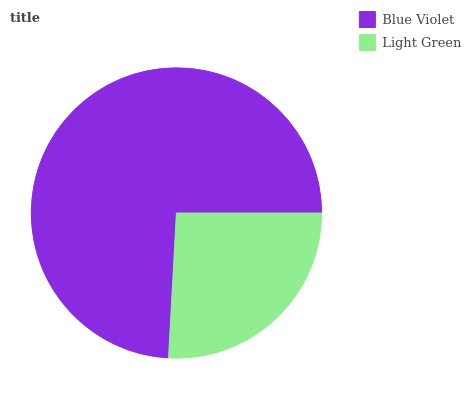Is Light Green the minimum?
Answer yes or no. Yes. Is Blue Violet the maximum?
Answer yes or no. Yes. Is Light Green the maximum?
Answer yes or no. No. Is Blue Violet greater than Light Green?
Answer yes or no. Yes. Is Light Green less than Blue Violet?
Answer yes or no. Yes. Is Light Green greater than Blue Violet?
Answer yes or no. No. Is Blue Violet less than Light Green?
Answer yes or no. No. Is Blue Violet the high median?
Answer yes or no. Yes. Is Light Green the low median?
Answer yes or no. Yes. Is Light Green the high median?
Answer yes or no. No. Is Blue Violet the low median?
Answer yes or no. No. 